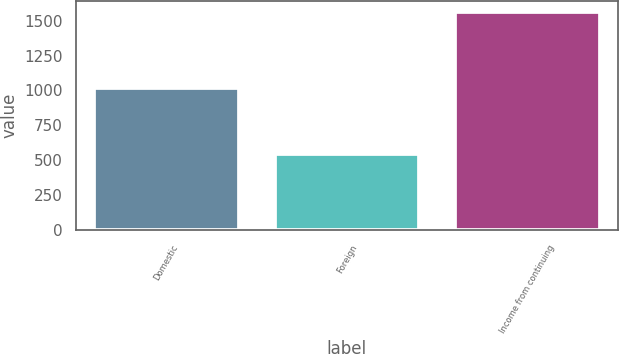Convert chart to OTSL. <chart><loc_0><loc_0><loc_500><loc_500><bar_chart><fcel>Domestic<fcel>Foreign<fcel>Income from continuing<nl><fcel>1015<fcel>548<fcel>1563<nl></chart> 